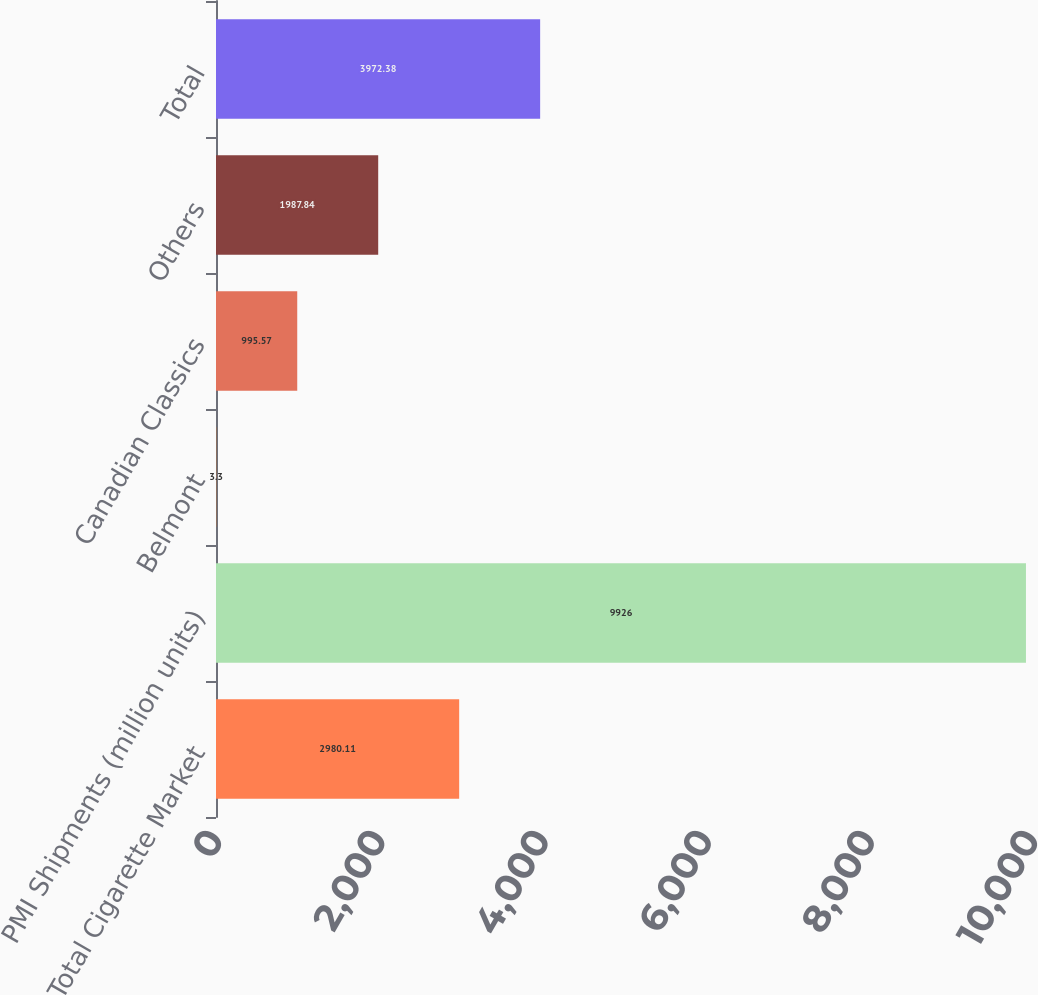Convert chart. <chart><loc_0><loc_0><loc_500><loc_500><bar_chart><fcel>Total Cigarette Market<fcel>PMI Shipments (million units)<fcel>Belmont<fcel>Canadian Classics<fcel>Others<fcel>Total<nl><fcel>2980.11<fcel>9926<fcel>3.3<fcel>995.57<fcel>1987.84<fcel>3972.38<nl></chart> 